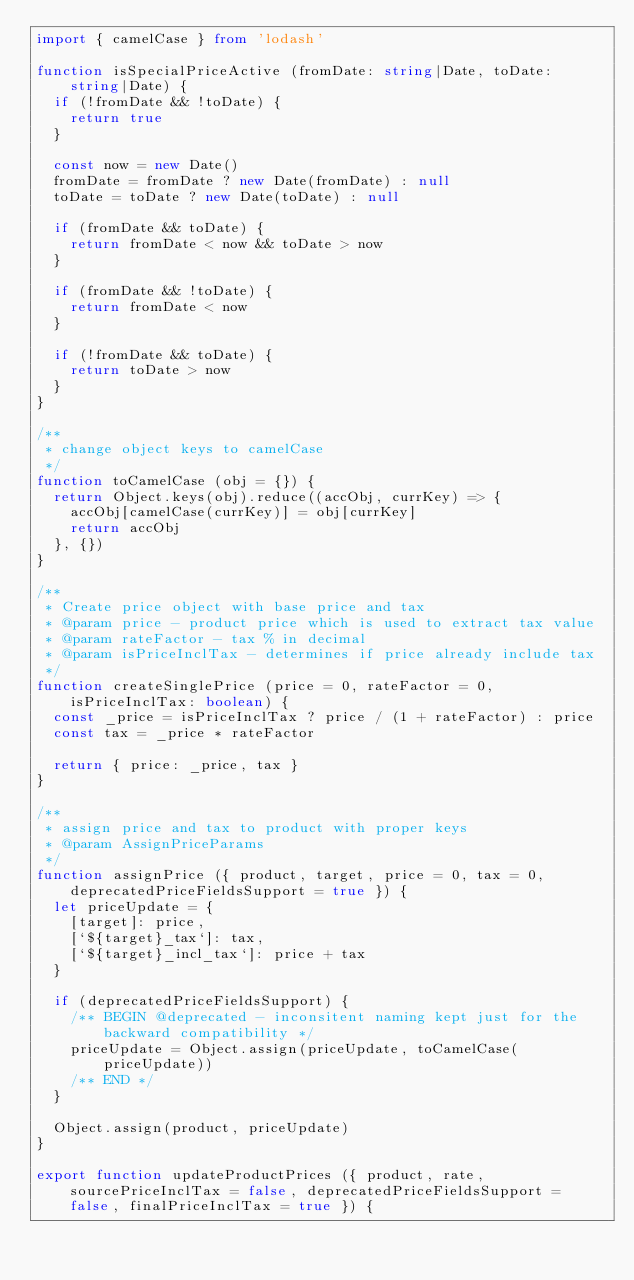<code> <loc_0><loc_0><loc_500><loc_500><_TypeScript_>import { camelCase } from 'lodash'

function isSpecialPriceActive (fromDate: string|Date, toDate: string|Date) {
  if (!fromDate && !toDate) {
    return true
  }

  const now = new Date()
  fromDate = fromDate ? new Date(fromDate) : null
  toDate = toDate ? new Date(toDate) : null

  if (fromDate && toDate) {
    return fromDate < now && toDate > now
  }

  if (fromDate && !toDate) {
    return fromDate < now
  }

  if (!fromDate && toDate) {
    return toDate > now
  }
}

/**
 * change object keys to camelCase
 */
function toCamelCase (obj = {}) {
  return Object.keys(obj).reduce((accObj, currKey) => {
    accObj[camelCase(currKey)] = obj[currKey]
    return accObj
  }, {})
}

/**
 * Create price object with base price and tax
 * @param price - product price which is used to extract tax value
 * @param rateFactor - tax % in decimal
 * @param isPriceInclTax - determines if price already include tax
 */
function createSinglePrice (price = 0, rateFactor = 0, isPriceInclTax: boolean) {
  const _price = isPriceInclTax ? price / (1 + rateFactor) : price
  const tax = _price * rateFactor

  return { price: _price, tax }
}

/**
 * assign price and tax to product with proper keys
 * @param AssignPriceParams
 */
function assignPrice ({ product, target, price = 0, tax = 0, deprecatedPriceFieldsSupport = true }) {
  let priceUpdate = {
    [target]: price,
    [`${target}_tax`]: tax,
    [`${target}_incl_tax`]: price + tax
  }

  if (deprecatedPriceFieldsSupport) {
    /** BEGIN @deprecated - inconsitent naming kept just for the backward compatibility */
    priceUpdate = Object.assign(priceUpdate, toCamelCase(priceUpdate))
    /** END */
  }

  Object.assign(product, priceUpdate)
}

export function updateProductPrices ({ product, rate, sourcePriceInclTax = false, deprecatedPriceFieldsSupport = false, finalPriceInclTax = true }) {</code> 